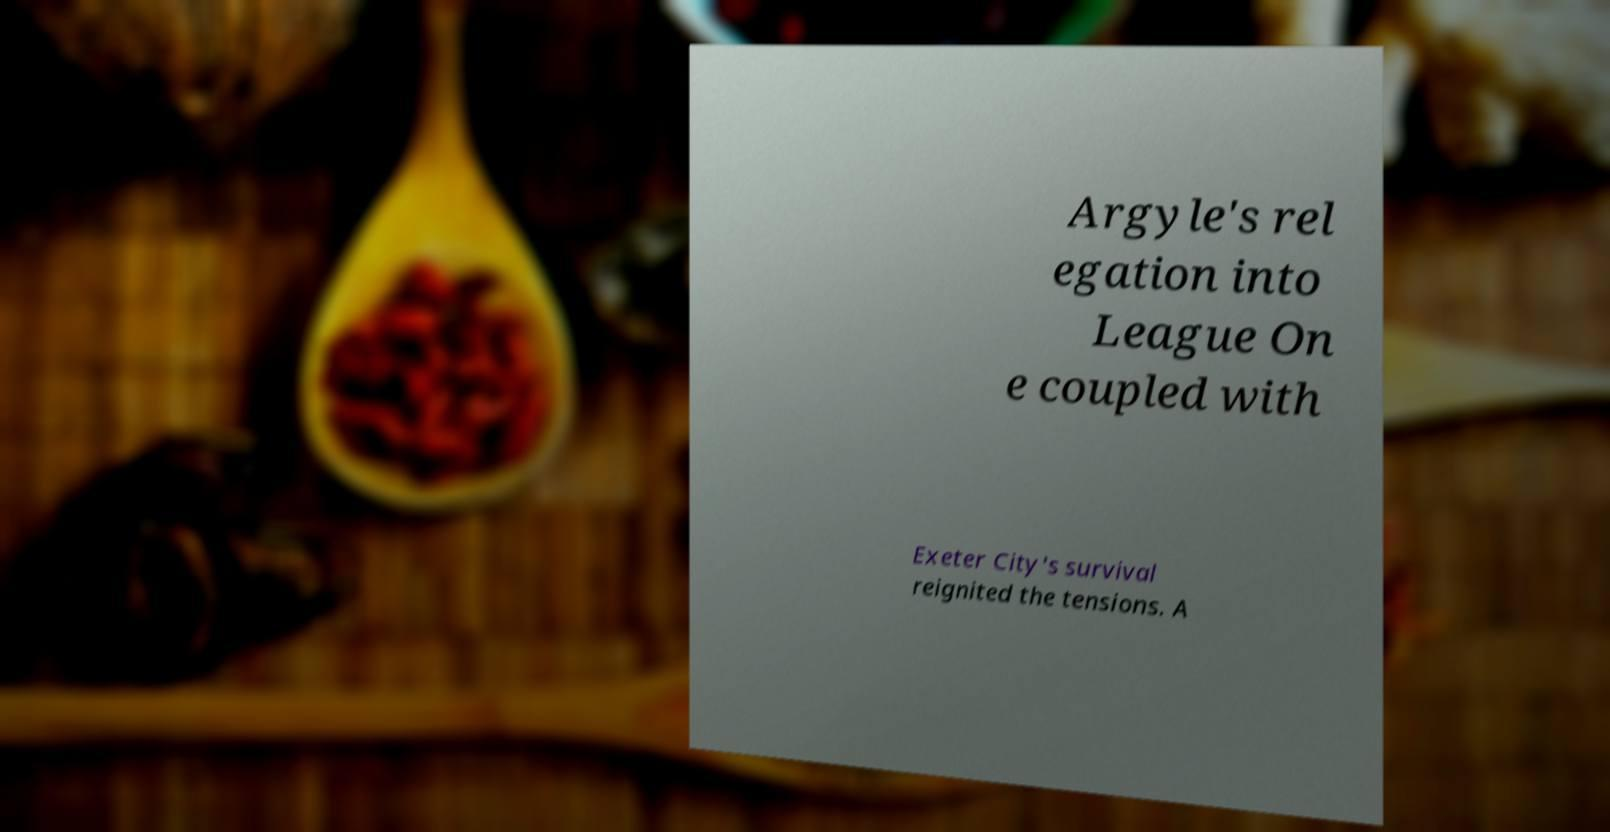Can you read and provide the text displayed in the image?This photo seems to have some interesting text. Can you extract and type it out for me? Argyle's rel egation into League On e coupled with Exeter City's survival reignited the tensions. A 